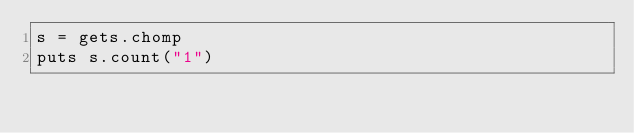Convert code to text. <code><loc_0><loc_0><loc_500><loc_500><_Ruby_>s = gets.chomp
puts s.count("1")</code> 